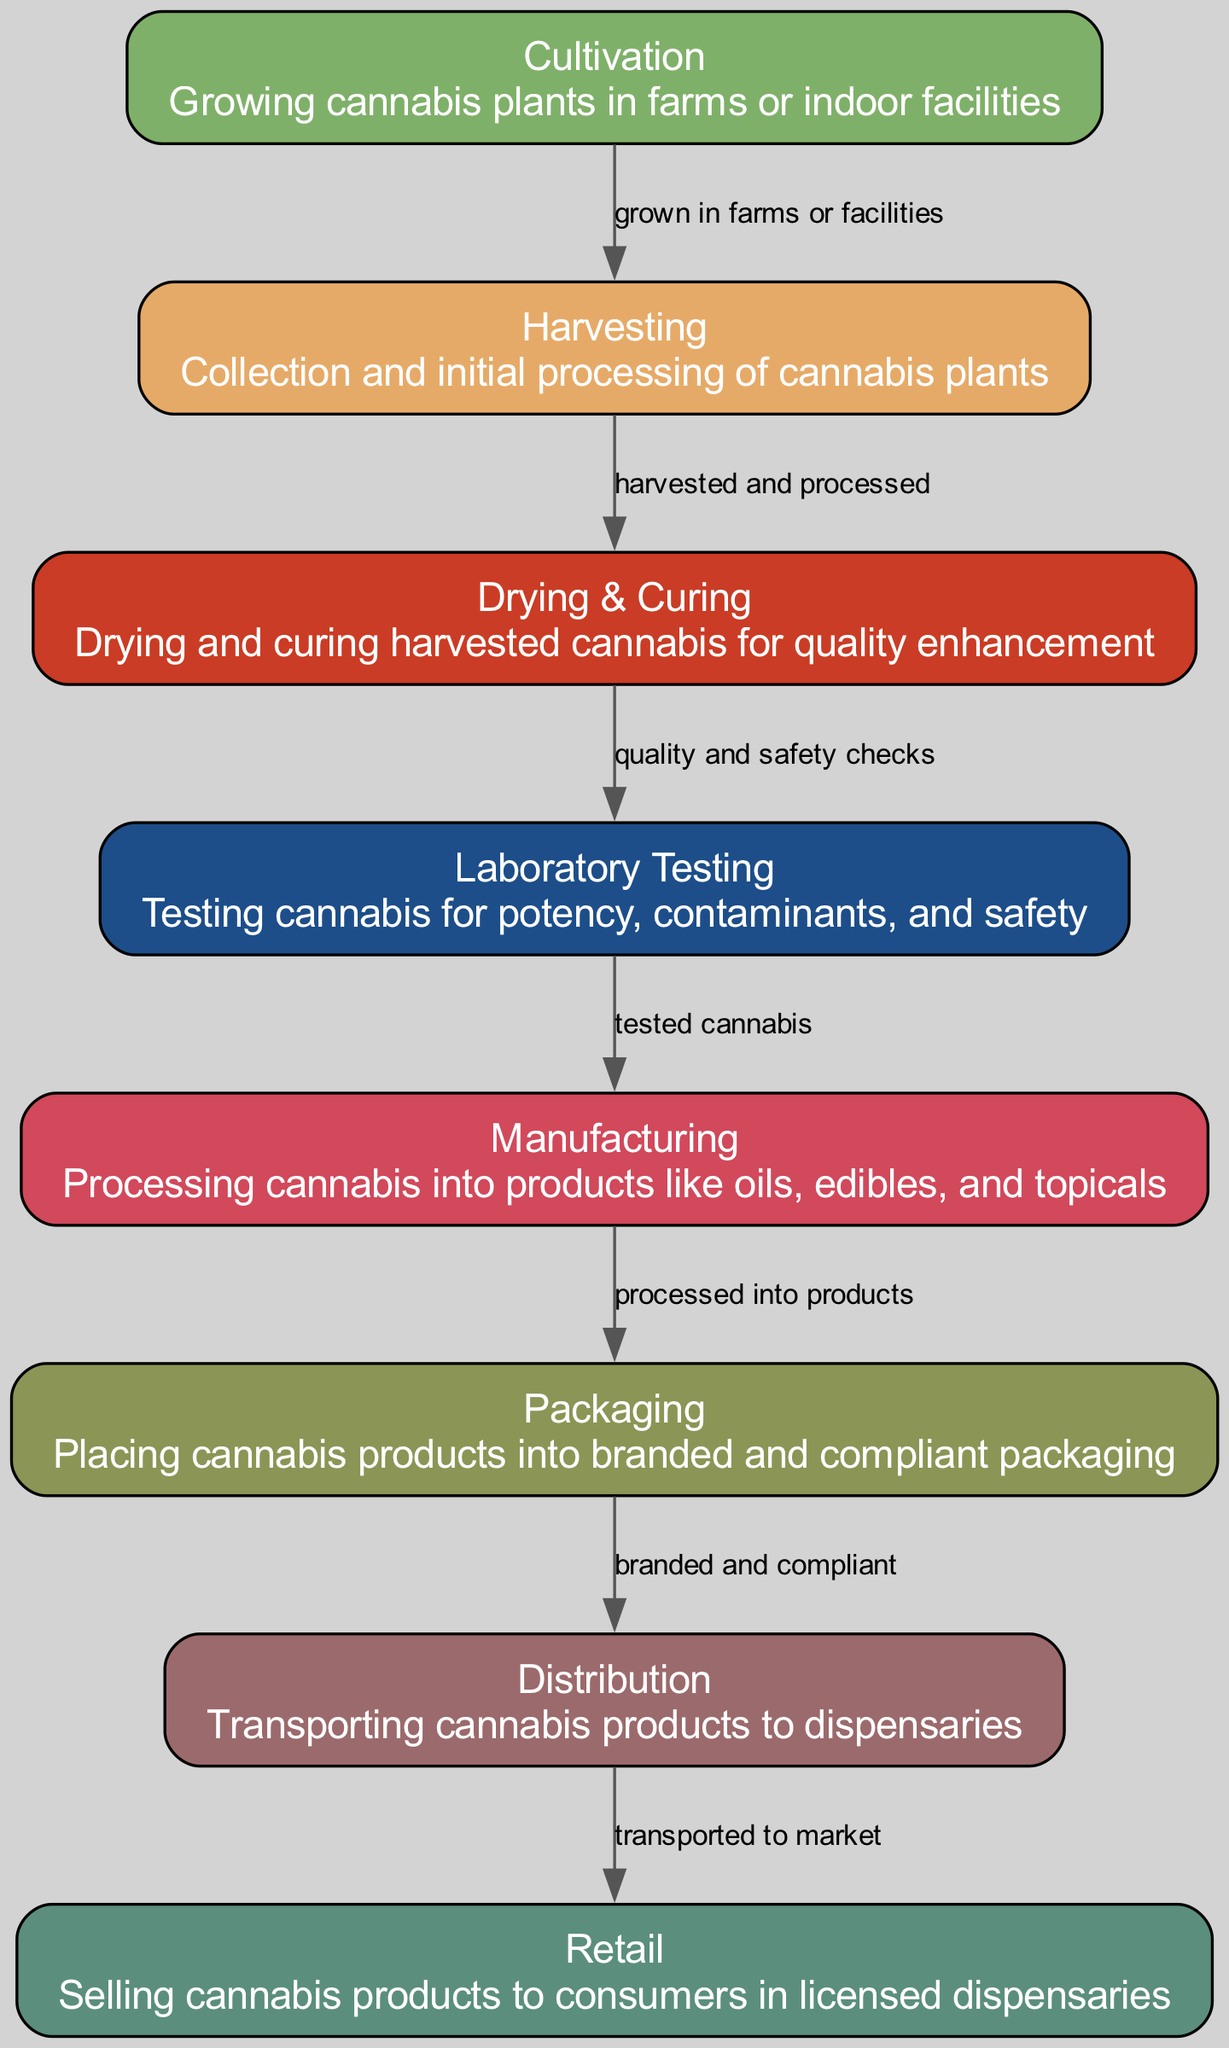What are the eight stages in the cannabis supply chain? The diagram contains eight nodes representing the stages: Cultivation, Harvesting, Drying & Curing, Laboratory Testing, Manufacturing, Packaging, Distribution, and Retail.
Answer: Eight What is the relationship between cultivation and harvesting? The arrow from cultivation to harvesting indicates that cannabis is grown in farms or facilities before being harvested.
Answer: Grown in farms or facilities What is the last step in the cannabis supply chain? The final node in the diagram shows that the last stage is Retail where cannabis products are sold to consumers.
Answer: Retail How many edges are there in the cannabis supply chain diagram? The diagram contains seven edges that represent the connections between the stages in the supply chain.
Answer: Seven What is tested before cannabis is sent to manufacturing? The arrow from testing to manufacturing signifies that only tested cannabis, checked for potency and contaminants, proceeds to manufacturing.
Answer: Tested cannabis Which node comes after drying & curing? According to the flow of the edges in the diagram, the node that follows drying & curing is testing, indicating that quality checks are performed afterward.
Answer: Testing What kind of products are created during the manufacturing stage? The manufacturing node indicates that cannabis is processed into products such as oils, edibles, and topicals.
Answer: Oils, edibles, and topicals Which nodes are directly connected to the packaging node? The diagram shows an edge leading from manufacturing to packaging, indicating that processed cannabis products are then packaged.
Answer: Manufacturing 